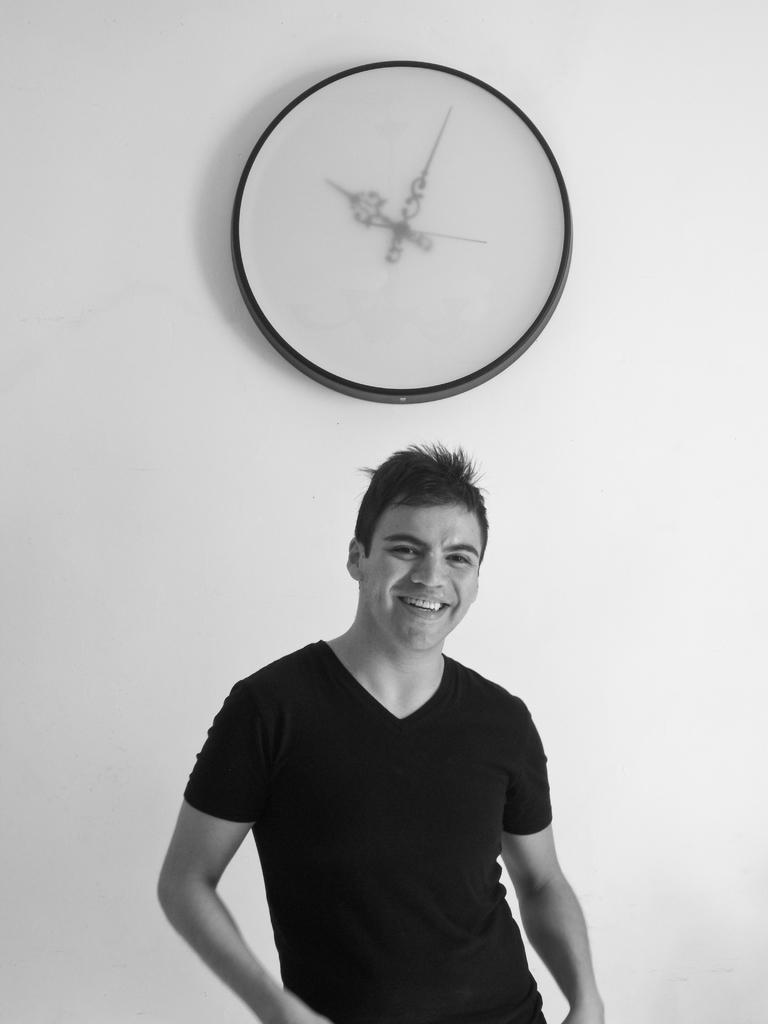What is present in the image? There is a man in the image. What is the man doing in the image? The man is smiling. What can be seen on the wall behind the man? There is a clock on the wall behind the man. What channel is the man watching on the television in the image? There is no television present in the image, so it is not possible to determine what channel the man might be watching. 